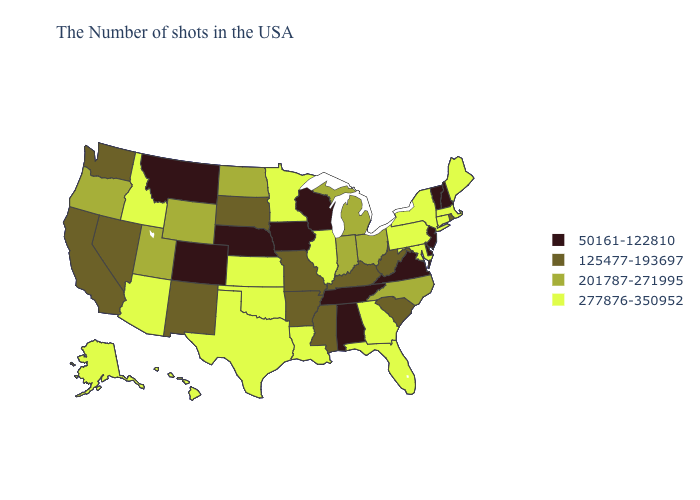Does Michigan have a lower value than Oklahoma?
Concise answer only. Yes. What is the value of Delaware?
Quick response, please. 50161-122810. Does West Virginia have the highest value in the USA?
Write a very short answer. No. Does the map have missing data?
Answer briefly. No. Name the states that have a value in the range 125477-193697?
Quick response, please. Rhode Island, South Carolina, West Virginia, Kentucky, Mississippi, Missouri, Arkansas, South Dakota, New Mexico, Nevada, California, Washington. Which states have the highest value in the USA?
Short answer required. Maine, Massachusetts, Connecticut, New York, Maryland, Pennsylvania, Florida, Georgia, Illinois, Louisiana, Minnesota, Kansas, Oklahoma, Texas, Arizona, Idaho, Alaska, Hawaii. What is the value of Wyoming?
Give a very brief answer. 201787-271995. What is the lowest value in the West?
Be succinct. 50161-122810. Name the states that have a value in the range 125477-193697?
Answer briefly. Rhode Island, South Carolina, West Virginia, Kentucky, Mississippi, Missouri, Arkansas, South Dakota, New Mexico, Nevada, California, Washington. Does the map have missing data?
Answer briefly. No. Name the states that have a value in the range 125477-193697?
Short answer required. Rhode Island, South Carolina, West Virginia, Kentucky, Mississippi, Missouri, Arkansas, South Dakota, New Mexico, Nevada, California, Washington. What is the lowest value in the USA?
Be succinct. 50161-122810. Is the legend a continuous bar?
Keep it brief. No. Does Arizona have the same value as Idaho?
Short answer required. Yes. What is the value of North Dakota?
Short answer required. 201787-271995. 